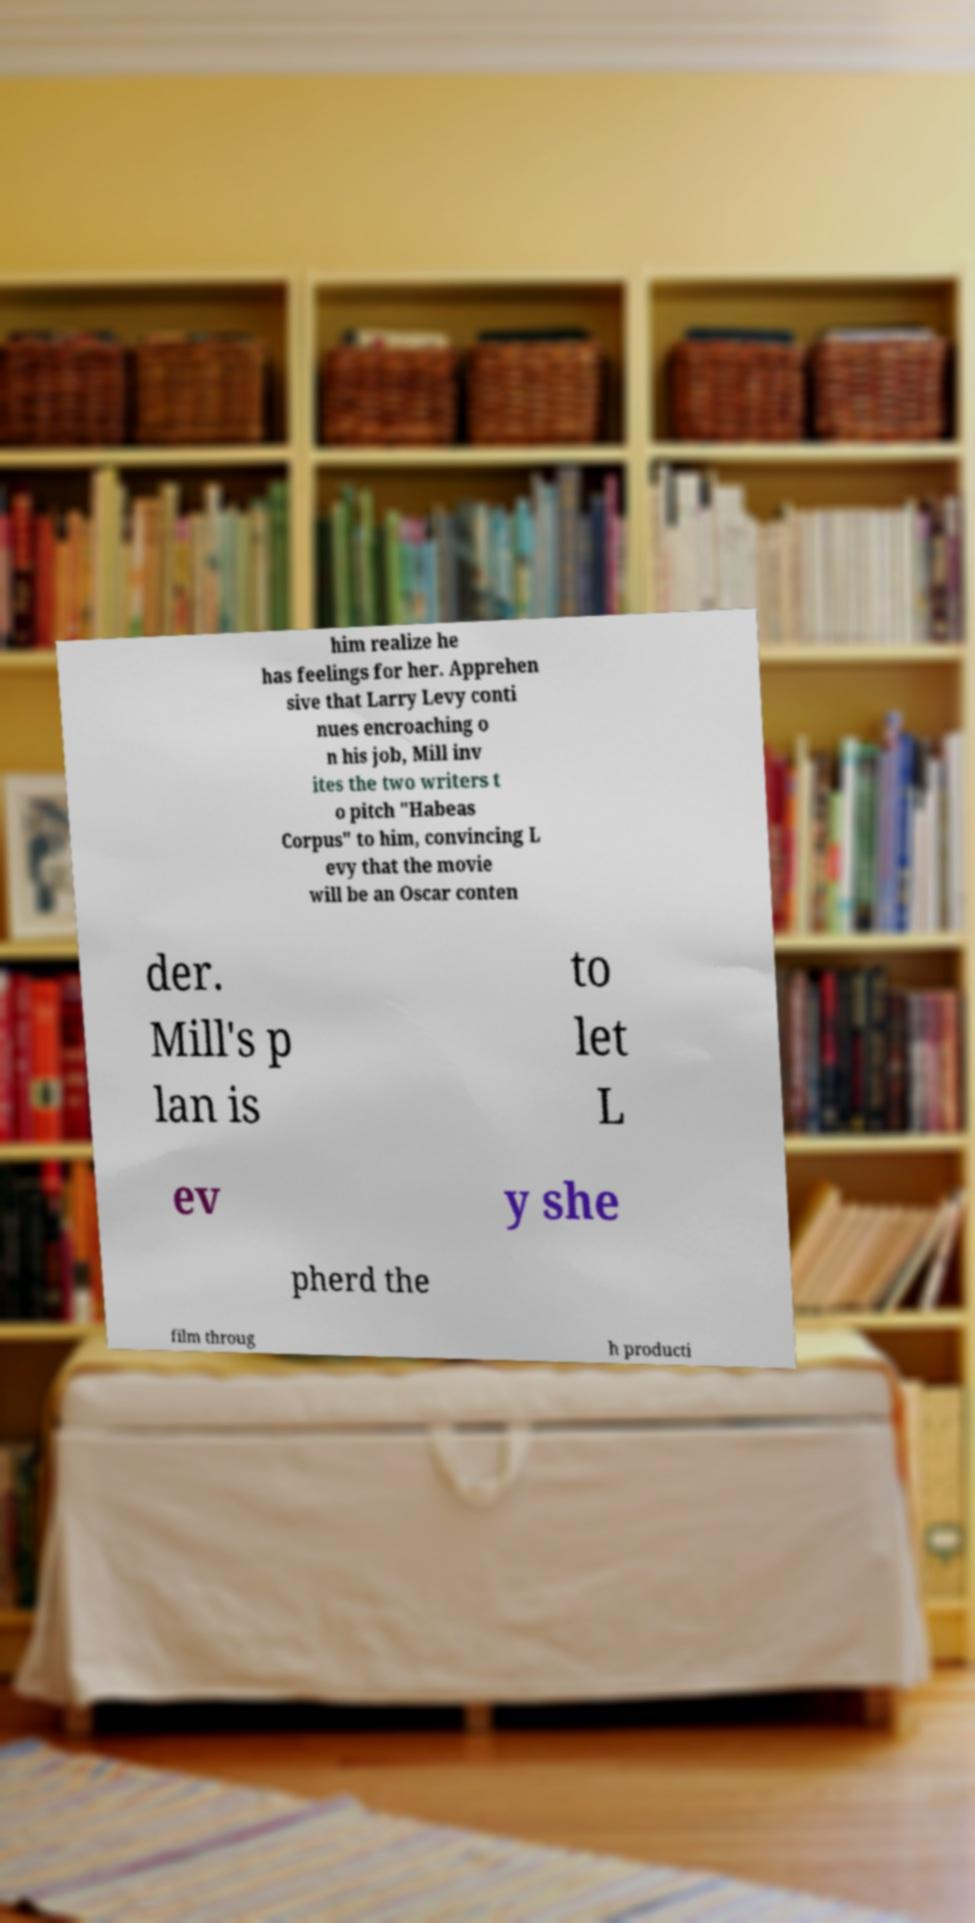Please identify and transcribe the text found in this image. him realize he has feelings for her. Apprehen sive that Larry Levy conti nues encroaching o n his job, Mill inv ites the two writers t o pitch "Habeas Corpus" to him, convincing L evy that the movie will be an Oscar conten der. Mill's p lan is to let L ev y she pherd the film throug h producti 